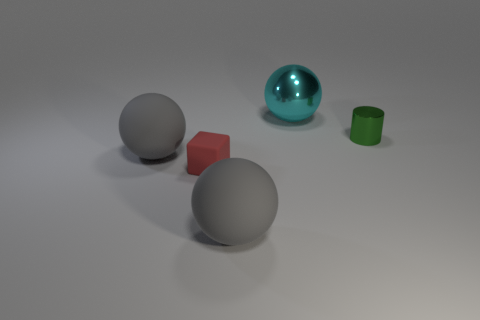Subtract all large gray balls. How many balls are left? 1 Subtract 1 balls. How many balls are left? 2 Add 4 large green metal cylinders. How many objects exist? 9 Subtract all cylinders. How many objects are left? 4 Add 2 small cyan metallic objects. How many small cyan metallic objects exist? 2 Subtract 0 green balls. How many objects are left? 5 Subtract all small purple metallic cylinders. Subtract all large cyan balls. How many objects are left? 4 Add 3 red matte cubes. How many red matte cubes are left? 4 